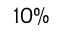Convert formula to latex. <formula><loc_0><loc_0><loc_500><loc_500>1 0 \%</formula> 